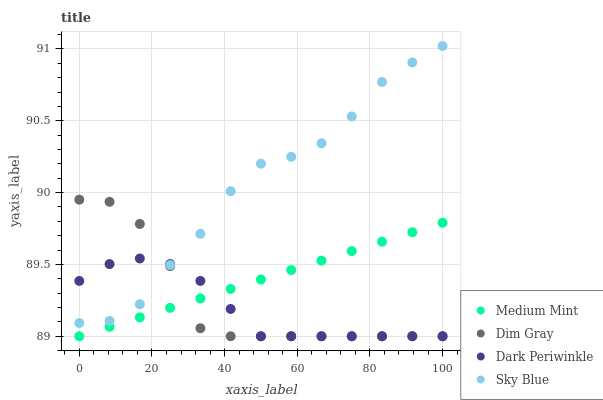Does Dark Periwinkle have the minimum area under the curve?
Answer yes or no. Yes. Does Sky Blue have the maximum area under the curve?
Answer yes or no. Yes. Does Dim Gray have the minimum area under the curve?
Answer yes or no. No. Does Dim Gray have the maximum area under the curve?
Answer yes or no. No. Is Medium Mint the smoothest?
Answer yes or no. Yes. Is Sky Blue the roughest?
Answer yes or no. Yes. Is Dim Gray the smoothest?
Answer yes or no. No. Is Dim Gray the roughest?
Answer yes or no. No. Does Medium Mint have the lowest value?
Answer yes or no. Yes. Does Sky Blue have the lowest value?
Answer yes or no. No. Does Sky Blue have the highest value?
Answer yes or no. Yes. Does Dim Gray have the highest value?
Answer yes or no. No. Is Medium Mint less than Sky Blue?
Answer yes or no. Yes. Is Sky Blue greater than Medium Mint?
Answer yes or no. Yes. Does Dim Gray intersect Dark Periwinkle?
Answer yes or no. Yes. Is Dim Gray less than Dark Periwinkle?
Answer yes or no. No. Is Dim Gray greater than Dark Periwinkle?
Answer yes or no. No. Does Medium Mint intersect Sky Blue?
Answer yes or no. No. 